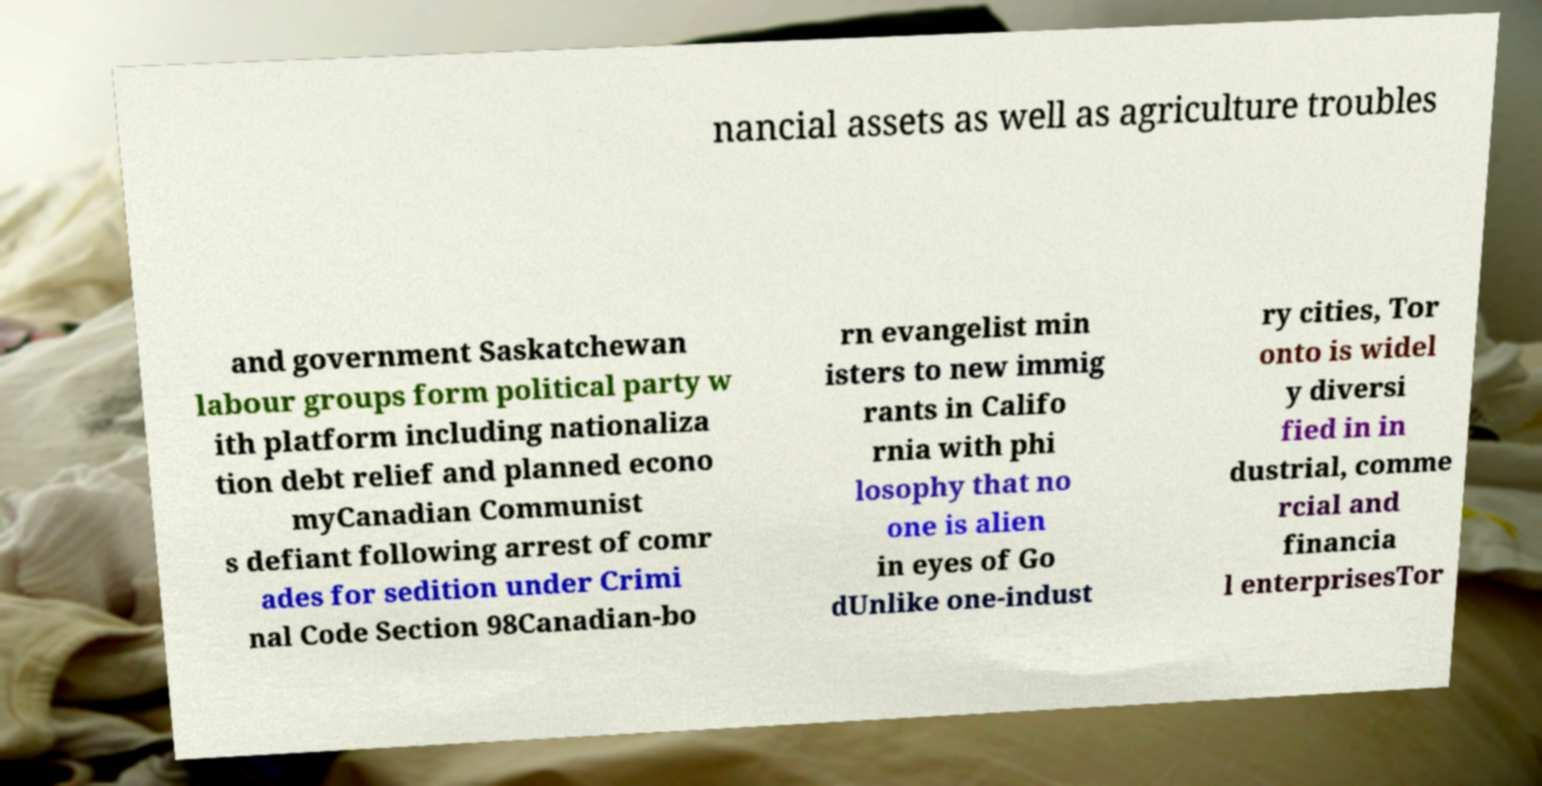There's text embedded in this image that I need extracted. Can you transcribe it verbatim? nancial assets as well as agriculture troubles and government Saskatchewan labour groups form political party w ith platform including nationaliza tion debt relief and planned econo myCanadian Communist s defiant following arrest of comr ades for sedition under Crimi nal Code Section 98Canadian-bo rn evangelist min isters to new immig rants in Califo rnia with phi losophy that no one is alien in eyes of Go dUnlike one-indust ry cities, Tor onto is widel y diversi fied in in dustrial, comme rcial and financia l enterprisesTor 